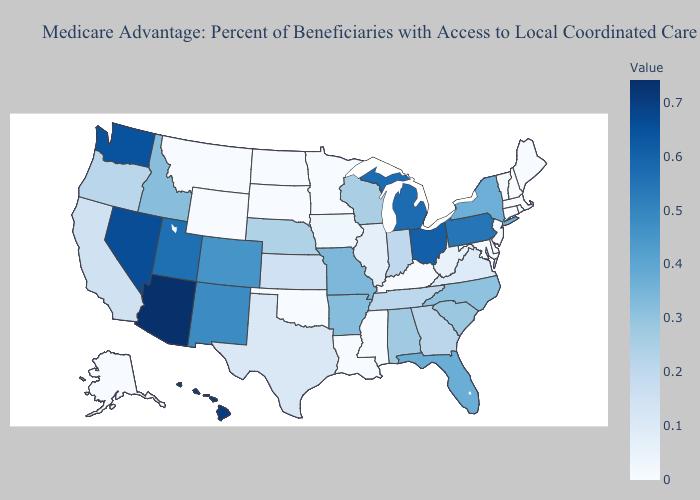Is the legend a continuous bar?
Concise answer only. Yes. Does Ohio have a lower value than Arizona?
Quick response, please. Yes. Among the states that border Illinois , does Kentucky have the lowest value?
Keep it brief. Yes. 